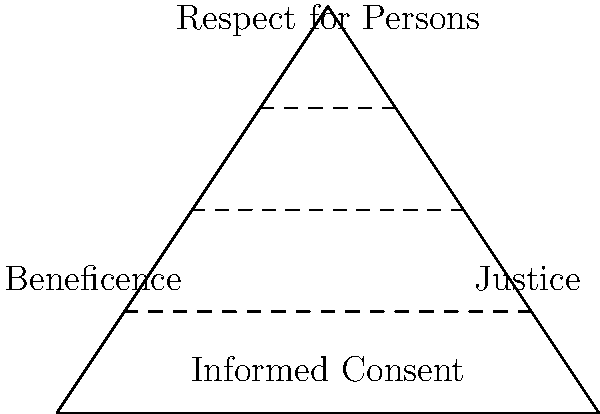In the ethical pyramid for human subject research, which principle forms the base and is most closely associated with the concept of voluntary participation? To answer this question, let's analyze the ethical pyramid for human subject research step-by-step:

1. The pyramid consists of four main components, arranged in a hierarchical structure.

2. At the top of the pyramid, we see "Respect for Persons," which is a fundamental principle in bioethics.

3. The middle layer of the pyramid is divided into two principles: "Beneficence" on the left and "Justice" on the right.

4. At the base of the pyramid, we find "Informed Consent."

5. Informed consent is the process by which potential research participants are provided with all relevant information about a study, its risks, and benefits, allowing them to make a voluntary decision about participation.

6. This principle is closely tied to the concept of voluntary participation, as it ensures that individuals have the autonomy to decide whether or not to participate in research based on a full understanding of what is involved.

7. The placement of informed consent at the base of the pyramid suggests that it is a foundational principle upon which other ethical considerations in human subject research are built.

Therefore, the principle that forms the base of the ethical pyramid and is most closely associated with voluntary participation is Informed Consent.
Answer: Informed Consent 